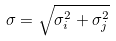Convert formula to latex. <formula><loc_0><loc_0><loc_500><loc_500>\sigma = \sqrt { \sigma _ { i } ^ { 2 } + \sigma _ { j } ^ { 2 } }</formula> 